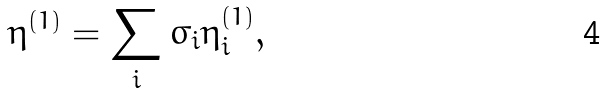Convert formula to latex. <formula><loc_0><loc_0><loc_500><loc_500>\eta ^ { ( 1 ) } = \sum _ { i } \sigma _ { i } \eta ^ { ( 1 ) } _ { i } ,</formula> 